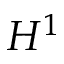<formula> <loc_0><loc_0><loc_500><loc_500>H ^ { 1 }</formula> 